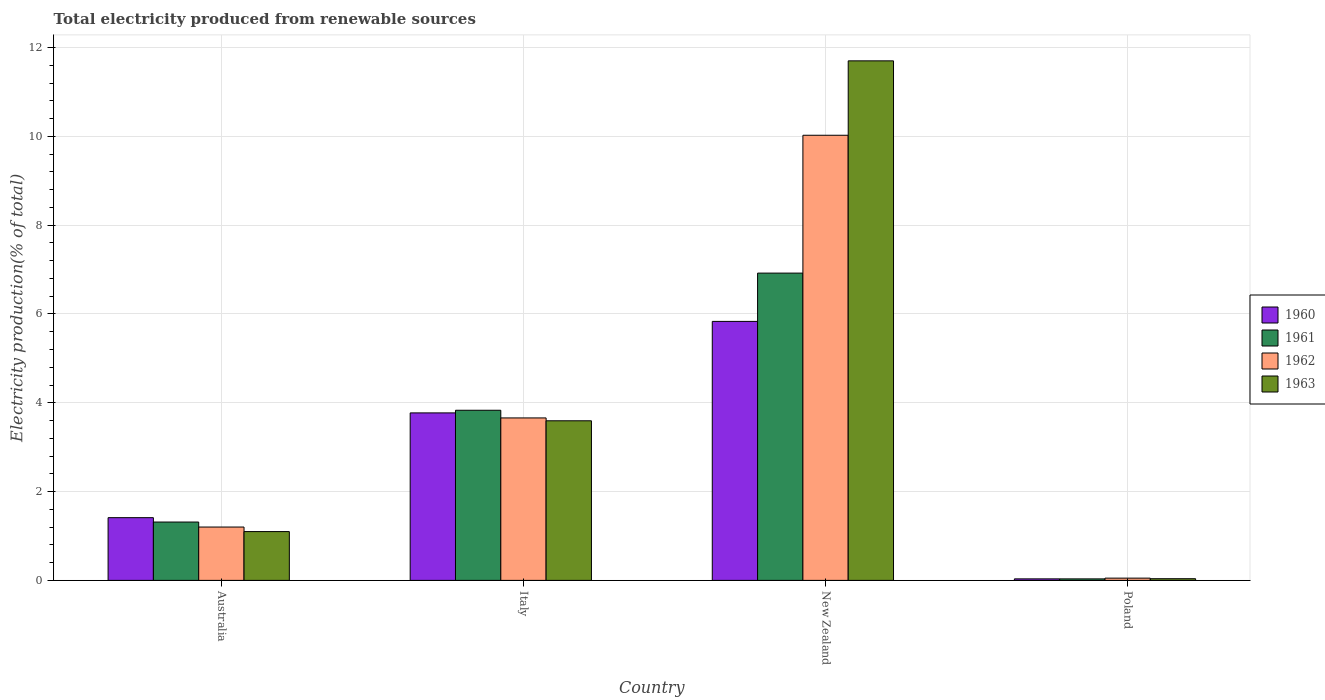How many different coloured bars are there?
Your response must be concise. 4. How many groups of bars are there?
Make the answer very short. 4. How many bars are there on the 4th tick from the left?
Your answer should be very brief. 4. What is the total electricity produced in 1962 in Italy?
Keep it short and to the point. 3.66. Across all countries, what is the maximum total electricity produced in 1960?
Offer a very short reply. 5.83. Across all countries, what is the minimum total electricity produced in 1960?
Offer a terse response. 0.03. In which country was the total electricity produced in 1962 maximum?
Provide a short and direct response. New Zealand. In which country was the total electricity produced in 1961 minimum?
Give a very brief answer. Poland. What is the total total electricity produced in 1963 in the graph?
Make the answer very short. 16.43. What is the difference between the total electricity produced in 1963 in Australia and that in Italy?
Make the answer very short. -2.5. What is the difference between the total electricity produced in 1961 in Australia and the total electricity produced in 1963 in Poland?
Ensure brevity in your answer.  1.28. What is the average total electricity produced in 1963 per country?
Keep it short and to the point. 4.11. What is the difference between the total electricity produced of/in 1961 and total electricity produced of/in 1963 in Italy?
Ensure brevity in your answer.  0.24. What is the ratio of the total electricity produced in 1960 in Italy to that in Poland?
Your response must be concise. 110.45. Is the total electricity produced in 1960 in Australia less than that in New Zealand?
Provide a short and direct response. Yes. What is the difference between the highest and the second highest total electricity produced in 1960?
Offer a very short reply. -2.36. What is the difference between the highest and the lowest total electricity produced in 1960?
Offer a terse response. 5.8. Is it the case that in every country, the sum of the total electricity produced in 1962 and total electricity produced in 1960 is greater than the sum of total electricity produced in 1963 and total electricity produced in 1961?
Your answer should be very brief. No. How many bars are there?
Provide a short and direct response. 16. How many countries are there in the graph?
Offer a very short reply. 4. Are the values on the major ticks of Y-axis written in scientific E-notation?
Keep it short and to the point. No. Does the graph contain any zero values?
Offer a terse response. No. Does the graph contain grids?
Give a very brief answer. Yes. Where does the legend appear in the graph?
Offer a terse response. Center right. What is the title of the graph?
Provide a succinct answer. Total electricity produced from renewable sources. What is the label or title of the X-axis?
Ensure brevity in your answer.  Country. What is the Electricity production(% of total) of 1960 in Australia?
Provide a short and direct response. 1.41. What is the Electricity production(% of total) of 1961 in Australia?
Offer a very short reply. 1.31. What is the Electricity production(% of total) in 1962 in Australia?
Keep it short and to the point. 1.2. What is the Electricity production(% of total) in 1963 in Australia?
Ensure brevity in your answer.  1.1. What is the Electricity production(% of total) of 1960 in Italy?
Give a very brief answer. 3.77. What is the Electricity production(% of total) in 1961 in Italy?
Keep it short and to the point. 3.83. What is the Electricity production(% of total) of 1962 in Italy?
Give a very brief answer. 3.66. What is the Electricity production(% of total) of 1963 in Italy?
Give a very brief answer. 3.59. What is the Electricity production(% of total) of 1960 in New Zealand?
Offer a very short reply. 5.83. What is the Electricity production(% of total) of 1961 in New Zealand?
Ensure brevity in your answer.  6.92. What is the Electricity production(% of total) of 1962 in New Zealand?
Give a very brief answer. 10.02. What is the Electricity production(% of total) in 1963 in New Zealand?
Your response must be concise. 11.7. What is the Electricity production(% of total) of 1960 in Poland?
Offer a very short reply. 0.03. What is the Electricity production(% of total) in 1961 in Poland?
Keep it short and to the point. 0.03. What is the Electricity production(% of total) in 1962 in Poland?
Keep it short and to the point. 0.05. What is the Electricity production(% of total) of 1963 in Poland?
Make the answer very short. 0.04. Across all countries, what is the maximum Electricity production(% of total) of 1960?
Offer a very short reply. 5.83. Across all countries, what is the maximum Electricity production(% of total) of 1961?
Provide a short and direct response. 6.92. Across all countries, what is the maximum Electricity production(% of total) of 1962?
Your answer should be compact. 10.02. Across all countries, what is the maximum Electricity production(% of total) in 1963?
Offer a terse response. 11.7. Across all countries, what is the minimum Electricity production(% of total) in 1960?
Your response must be concise. 0.03. Across all countries, what is the minimum Electricity production(% of total) in 1961?
Offer a very short reply. 0.03. Across all countries, what is the minimum Electricity production(% of total) in 1962?
Ensure brevity in your answer.  0.05. Across all countries, what is the minimum Electricity production(% of total) in 1963?
Provide a short and direct response. 0.04. What is the total Electricity production(% of total) in 1960 in the graph?
Your answer should be compact. 11.05. What is the total Electricity production(% of total) of 1961 in the graph?
Provide a short and direct response. 12.1. What is the total Electricity production(% of total) of 1962 in the graph?
Keep it short and to the point. 14.94. What is the total Electricity production(% of total) of 1963 in the graph?
Your answer should be compact. 16.43. What is the difference between the Electricity production(% of total) in 1960 in Australia and that in Italy?
Offer a terse response. -2.36. What is the difference between the Electricity production(% of total) of 1961 in Australia and that in Italy?
Keep it short and to the point. -2.52. What is the difference between the Electricity production(% of total) in 1962 in Australia and that in Italy?
Offer a very short reply. -2.46. What is the difference between the Electricity production(% of total) of 1963 in Australia and that in Italy?
Offer a very short reply. -2.5. What is the difference between the Electricity production(% of total) of 1960 in Australia and that in New Zealand?
Your response must be concise. -4.42. What is the difference between the Electricity production(% of total) of 1961 in Australia and that in New Zealand?
Keep it short and to the point. -5.61. What is the difference between the Electricity production(% of total) of 1962 in Australia and that in New Zealand?
Your answer should be very brief. -8.82. What is the difference between the Electricity production(% of total) in 1963 in Australia and that in New Zealand?
Offer a very short reply. -10.6. What is the difference between the Electricity production(% of total) in 1960 in Australia and that in Poland?
Ensure brevity in your answer.  1.38. What is the difference between the Electricity production(% of total) in 1961 in Australia and that in Poland?
Provide a succinct answer. 1.28. What is the difference between the Electricity production(% of total) in 1962 in Australia and that in Poland?
Make the answer very short. 1.15. What is the difference between the Electricity production(% of total) of 1963 in Australia and that in Poland?
Your response must be concise. 1.06. What is the difference between the Electricity production(% of total) in 1960 in Italy and that in New Zealand?
Offer a terse response. -2.06. What is the difference between the Electricity production(% of total) in 1961 in Italy and that in New Zealand?
Your answer should be very brief. -3.09. What is the difference between the Electricity production(% of total) in 1962 in Italy and that in New Zealand?
Keep it short and to the point. -6.37. What is the difference between the Electricity production(% of total) of 1963 in Italy and that in New Zealand?
Provide a succinct answer. -8.11. What is the difference between the Electricity production(% of total) in 1960 in Italy and that in Poland?
Make the answer very short. 3.74. What is the difference between the Electricity production(% of total) of 1961 in Italy and that in Poland?
Keep it short and to the point. 3.8. What is the difference between the Electricity production(% of total) of 1962 in Italy and that in Poland?
Offer a terse response. 3.61. What is the difference between the Electricity production(% of total) of 1963 in Italy and that in Poland?
Provide a succinct answer. 3.56. What is the difference between the Electricity production(% of total) of 1960 in New Zealand and that in Poland?
Your response must be concise. 5.8. What is the difference between the Electricity production(% of total) in 1961 in New Zealand and that in Poland?
Your answer should be compact. 6.89. What is the difference between the Electricity production(% of total) of 1962 in New Zealand and that in Poland?
Your response must be concise. 9.97. What is the difference between the Electricity production(% of total) of 1963 in New Zealand and that in Poland?
Offer a terse response. 11.66. What is the difference between the Electricity production(% of total) of 1960 in Australia and the Electricity production(% of total) of 1961 in Italy?
Your response must be concise. -2.42. What is the difference between the Electricity production(% of total) in 1960 in Australia and the Electricity production(% of total) in 1962 in Italy?
Your answer should be very brief. -2.25. What is the difference between the Electricity production(% of total) in 1960 in Australia and the Electricity production(% of total) in 1963 in Italy?
Keep it short and to the point. -2.18. What is the difference between the Electricity production(% of total) in 1961 in Australia and the Electricity production(% of total) in 1962 in Italy?
Provide a short and direct response. -2.34. What is the difference between the Electricity production(% of total) of 1961 in Australia and the Electricity production(% of total) of 1963 in Italy?
Provide a short and direct response. -2.28. What is the difference between the Electricity production(% of total) of 1962 in Australia and the Electricity production(% of total) of 1963 in Italy?
Offer a terse response. -2.39. What is the difference between the Electricity production(% of total) in 1960 in Australia and the Electricity production(% of total) in 1961 in New Zealand?
Provide a short and direct response. -5.51. What is the difference between the Electricity production(% of total) in 1960 in Australia and the Electricity production(% of total) in 1962 in New Zealand?
Provide a short and direct response. -8.61. What is the difference between the Electricity production(% of total) of 1960 in Australia and the Electricity production(% of total) of 1963 in New Zealand?
Your answer should be very brief. -10.29. What is the difference between the Electricity production(% of total) in 1961 in Australia and the Electricity production(% of total) in 1962 in New Zealand?
Keep it short and to the point. -8.71. What is the difference between the Electricity production(% of total) in 1961 in Australia and the Electricity production(% of total) in 1963 in New Zealand?
Offer a very short reply. -10.39. What is the difference between the Electricity production(% of total) in 1962 in Australia and the Electricity production(% of total) in 1963 in New Zealand?
Your answer should be very brief. -10.5. What is the difference between the Electricity production(% of total) of 1960 in Australia and the Electricity production(% of total) of 1961 in Poland?
Your response must be concise. 1.38. What is the difference between the Electricity production(% of total) of 1960 in Australia and the Electricity production(% of total) of 1962 in Poland?
Keep it short and to the point. 1.36. What is the difference between the Electricity production(% of total) of 1960 in Australia and the Electricity production(% of total) of 1963 in Poland?
Offer a very short reply. 1.37. What is the difference between the Electricity production(% of total) of 1961 in Australia and the Electricity production(% of total) of 1962 in Poland?
Offer a terse response. 1.26. What is the difference between the Electricity production(% of total) of 1961 in Australia and the Electricity production(% of total) of 1963 in Poland?
Offer a very short reply. 1.28. What is the difference between the Electricity production(% of total) in 1962 in Australia and the Electricity production(% of total) in 1963 in Poland?
Offer a terse response. 1.16. What is the difference between the Electricity production(% of total) in 1960 in Italy and the Electricity production(% of total) in 1961 in New Zealand?
Keep it short and to the point. -3.15. What is the difference between the Electricity production(% of total) of 1960 in Italy and the Electricity production(% of total) of 1962 in New Zealand?
Your answer should be very brief. -6.25. What is the difference between the Electricity production(% of total) in 1960 in Italy and the Electricity production(% of total) in 1963 in New Zealand?
Make the answer very short. -7.93. What is the difference between the Electricity production(% of total) in 1961 in Italy and the Electricity production(% of total) in 1962 in New Zealand?
Offer a very short reply. -6.19. What is the difference between the Electricity production(% of total) of 1961 in Italy and the Electricity production(% of total) of 1963 in New Zealand?
Your response must be concise. -7.87. What is the difference between the Electricity production(% of total) in 1962 in Italy and the Electricity production(% of total) in 1963 in New Zealand?
Your response must be concise. -8.04. What is the difference between the Electricity production(% of total) in 1960 in Italy and the Electricity production(% of total) in 1961 in Poland?
Keep it short and to the point. 3.74. What is the difference between the Electricity production(% of total) of 1960 in Italy and the Electricity production(% of total) of 1962 in Poland?
Your answer should be compact. 3.72. What is the difference between the Electricity production(% of total) in 1960 in Italy and the Electricity production(% of total) in 1963 in Poland?
Provide a short and direct response. 3.73. What is the difference between the Electricity production(% of total) of 1961 in Italy and the Electricity production(% of total) of 1962 in Poland?
Your answer should be very brief. 3.78. What is the difference between the Electricity production(% of total) in 1961 in Italy and the Electricity production(% of total) in 1963 in Poland?
Keep it short and to the point. 3.79. What is the difference between the Electricity production(% of total) of 1962 in Italy and the Electricity production(% of total) of 1963 in Poland?
Provide a succinct answer. 3.62. What is the difference between the Electricity production(% of total) in 1960 in New Zealand and the Electricity production(% of total) in 1961 in Poland?
Your answer should be very brief. 5.8. What is the difference between the Electricity production(% of total) of 1960 in New Zealand and the Electricity production(% of total) of 1962 in Poland?
Make the answer very short. 5.78. What is the difference between the Electricity production(% of total) in 1960 in New Zealand and the Electricity production(% of total) in 1963 in Poland?
Keep it short and to the point. 5.79. What is the difference between the Electricity production(% of total) in 1961 in New Zealand and the Electricity production(% of total) in 1962 in Poland?
Your answer should be very brief. 6.87. What is the difference between the Electricity production(% of total) of 1961 in New Zealand and the Electricity production(% of total) of 1963 in Poland?
Keep it short and to the point. 6.88. What is the difference between the Electricity production(% of total) in 1962 in New Zealand and the Electricity production(% of total) in 1963 in Poland?
Make the answer very short. 9.99. What is the average Electricity production(% of total) in 1960 per country?
Provide a short and direct response. 2.76. What is the average Electricity production(% of total) of 1961 per country?
Ensure brevity in your answer.  3.02. What is the average Electricity production(% of total) in 1962 per country?
Ensure brevity in your answer.  3.73. What is the average Electricity production(% of total) of 1963 per country?
Offer a very short reply. 4.11. What is the difference between the Electricity production(% of total) in 1960 and Electricity production(% of total) in 1961 in Australia?
Ensure brevity in your answer.  0.1. What is the difference between the Electricity production(% of total) of 1960 and Electricity production(% of total) of 1962 in Australia?
Give a very brief answer. 0.21. What is the difference between the Electricity production(% of total) of 1960 and Electricity production(% of total) of 1963 in Australia?
Give a very brief answer. 0.31. What is the difference between the Electricity production(% of total) of 1961 and Electricity production(% of total) of 1962 in Australia?
Provide a succinct answer. 0.11. What is the difference between the Electricity production(% of total) in 1961 and Electricity production(% of total) in 1963 in Australia?
Ensure brevity in your answer.  0.21. What is the difference between the Electricity production(% of total) in 1962 and Electricity production(% of total) in 1963 in Australia?
Keep it short and to the point. 0.1. What is the difference between the Electricity production(% of total) in 1960 and Electricity production(% of total) in 1961 in Italy?
Keep it short and to the point. -0.06. What is the difference between the Electricity production(% of total) of 1960 and Electricity production(% of total) of 1962 in Italy?
Ensure brevity in your answer.  0.11. What is the difference between the Electricity production(% of total) in 1960 and Electricity production(% of total) in 1963 in Italy?
Provide a succinct answer. 0.18. What is the difference between the Electricity production(% of total) of 1961 and Electricity production(% of total) of 1962 in Italy?
Offer a terse response. 0.17. What is the difference between the Electricity production(% of total) of 1961 and Electricity production(% of total) of 1963 in Italy?
Offer a very short reply. 0.24. What is the difference between the Electricity production(% of total) in 1962 and Electricity production(% of total) in 1963 in Italy?
Provide a succinct answer. 0.06. What is the difference between the Electricity production(% of total) in 1960 and Electricity production(% of total) in 1961 in New Zealand?
Your answer should be compact. -1.09. What is the difference between the Electricity production(% of total) in 1960 and Electricity production(% of total) in 1962 in New Zealand?
Offer a very short reply. -4.19. What is the difference between the Electricity production(% of total) of 1960 and Electricity production(% of total) of 1963 in New Zealand?
Offer a terse response. -5.87. What is the difference between the Electricity production(% of total) of 1961 and Electricity production(% of total) of 1962 in New Zealand?
Keep it short and to the point. -3.1. What is the difference between the Electricity production(% of total) in 1961 and Electricity production(% of total) in 1963 in New Zealand?
Provide a succinct answer. -4.78. What is the difference between the Electricity production(% of total) in 1962 and Electricity production(% of total) in 1963 in New Zealand?
Provide a succinct answer. -1.68. What is the difference between the Electricity production(% of total) in 1960 and Electricity production(% of total) in 1961 in Poland?
Offer a terse response. 0. What is the difference between the Electricity production(% of total) in 1960 and Electricity production(% of total) in 1962 in Poland?
Your answer should be compact. -0.02. What is the difference between the Electricity production(% of total) in 1960 and Electricity production(% of total) in 1963 in Poland?
Your response must be concise. -0. What is the difference between the Electricity production(% of total) in 1961 and Electricity production(% of total) in 1962 in Poland?
Give a very brief answer. -0.02. What is the difference between the Electricity production(% of total) in 1961 and Electricity production(% of total) in 1963 in Poland?
Offer a very short reply. -0. What is the difference between the Electricity production(% of total) of 1962 and Electricity production(% of total) of 1963 in Poland?
Your answer should be compact. 0.01. What is the ratio of the Electricity production(% of total) in 1960 in Australia to that in Italy?
Provide a succinct answer. 0.37. What is the ratio of the Electricity production(% of total) in 1961 in Australia to that in Italy?
Keep it short and to the point. 0.34. What is the ratio of the Electricity production(% of total) in 1962 in Australia to that in Italy?
Provide a succinct answer. 0.33. What is the ratio of the Electricity production(% of total) in 1963 in Australia to that in Italy?
Your answer should be compact. 0.31. What is the ratio of the Electricity production(% of total) of 1960 in Australia to that in New Zealand?
Your response must be concise. 0.24. What is the ratio of the Electricity production(% of total) in 1961 in Australia to that in New Zealand?
Provide a short and direct response. 0.19. What is the ratio of the Electricity production(% of total) in 1962 in Australia to that in New Zealand?
Keep it short and to the point. 0.12. What is the ratio of the Electricity production(% of total) of 1963 in Australia to that in New Zealand?
Offer a very short reply. 0.09. What is the ratio of the Electricity production(% of total) of 1960 in Australia to that in Poland?
Your answer should be compact. 41.37. What is the ratio of the Electricity production(% of total) of 1961 in Australia to that in Poland?
Your answer should be compact. 38.51. What is the ratio of the Electricity production(% of total) of 1962 in Australia to that in Poland?
Your answer should be very brief. 23.61. What is the ratio of the Electricity production(% of total) in 1963 in Australia to that in Poland?
Give a very brief answer. 29. What is the ratio of the Electricity production(% of total) of 1960 in Italy to that in New Zealand?
Make the answer very short. 0.65. What is the ratio of the Electricity production(% of total) of 1961 in Italy to that in New Zealand?
Offer a terse response. 0.55. What is the ratio of the Electricity production(% of total) of 1962 in Italy to that in New Zealand?
Ensure brevity in your answer.  0.36. What is the ratio of the Electricity production(% of total) in 1963 in Italy to that in New Zealand?
Your answer should be compact. 0.31. What is the ratio of the Electricity production(% of total) in 1960 in Italy to that in Poland?
Your answer should be compact. 110.45. What is the ratio of the Electricity production(% of total) in 1961 in Italy to that in Poland?
Your answer should be compact. 112.3. What is the ratio of the Electricity production(% of total) in 1962 in Italy to that in Poland?
Provide a short and direct response. 71.88. What is the ratio of the Electricity production(% of total) of 1963 in Italy to that in Poland?
Your answer should be very brief. 94.84. What is the ratio of the Electricity production(% of total) in 1960 in New Zealand to that in Poland?
Provide a succinct answer. 170.79. What is the ratio of the Electricity production(% of total) of 1961 in New Zealand to that in Poland?
Offer a very short reply. 202.83. What is the ratio of the Electricity production(% of total) in 1962 in New Zealand to that in Poland?
Provide a succinct answer. 196.95. What is the ratio of the Electricity production(% of total) of 1963 in New Zealand to that in Poland?
Offer a terse response. 308.73. What is the difference between the highest and the second highest Electricity production(% of total) of 1960?
Offer a very short reply. 2.06. What is the difference between the highest and the second highest Electricity production(% of total) in 1961?
Offer a terse response. 3.09. What is the difference between the highest and the second highest Electricity production(% of total) in 1962?
Offer a very short reply. 6.37. What is the difference between the highest and the second highest Electricity production(% of total) of 1963?
Ensure brevity in your answer.  8.11. What is the difference between the highest and the lowest Electricity production(% of total) in 1960?
Offer a terse response. 5.8. What is the difference between the highest and the lowest Electricity production(% of total) of 1961?
Provide a short and direct response. 6.89. What is the difference between the highest and the lowest Electricity production(% of total) in 1962?
Ensure brevity in your answer.  9.97. What is the difference between the highest and the lowest Electricity production(% of total) of 1963?
Make the answer very short. 11.66. 